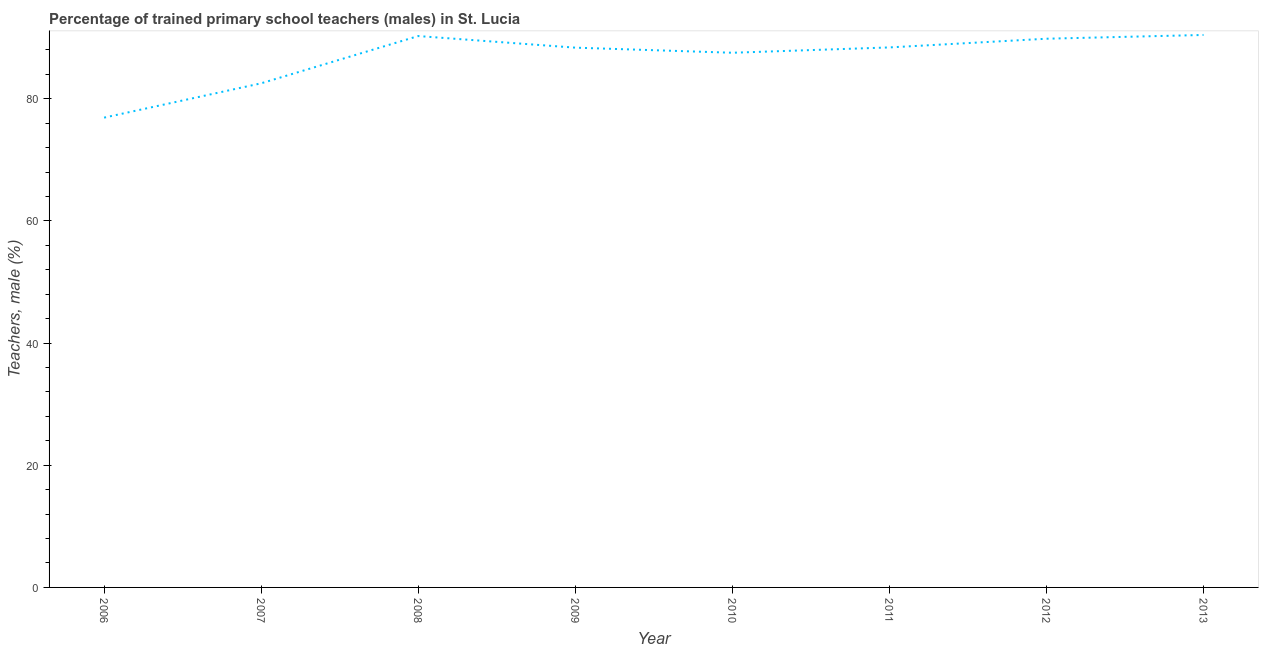What is the percentage of trained male teachers in 2012?
Your response must be concise. 89.82. Across all years, what is the maximum percentage of trained male teachers?
Keep it short and to the point. 90.44. Across all years, what is the minimum percentage of trained male teachers?
Provide a succinct answer. 76.91. In which year was the percentage of trained male teachers maximum?
Your answer should be very brief. 2013. In which year was the percentage of trained male teachers minimum?
Keep it short and to the point. 2006. What is the sum of the percentage of trained male teachers?
Provide a succinct answer. 694.25. What is the difference between the percentage of trained male teachers in 2008 and 2011?
Your answer should be very brief. 1.86. What is the average percentage of trained male teachers per year?
Ensure brevity in your answer.  86.78. What is the median percentage of trained male teachers?
Your response must be concise. 88.38. What is the ratio of the percentage of trained male teachers in 2010 to that in 2012?
Provide a succinct answer. 0.97. Is the percentage of trained male teachers in 2011 less than that in 2012?
Keep it short and to the point. Yes. What is the difference between the highest and the second highest percentage of trained male teachers?
Your answer should be very brief. 0.18. What is the difference between the highest and the lowest percentage of trained male teachers?
Your response must be concise. 13.53. In how many years, is the percentage of trained male teachers greater than the average percentage of trained male teachers taken over all years?
Your answer should be compact. 6. How many lines are there?
Provide a succinct answer. 1. How many years are there in the graph?
Your response must be concise. 8. What is the title of the graph?
Your answer should be very brief. Percentage of trained primary school teachers (males) in St. Lucia. What is the label or title of the X-axis?
Give a very brief answer. Year. What is the label or title of the Y-axis?
Make the answer very short. Teachers, male (%). What is the Teachers, male (%) of 2006?
Offer a terse response. 76.91. What is the Teachers, male (%) of 2007?
Give a very brief answer. 82.53. What is the Teachers, male (%) of 2008?
Provide a short and direct response. 90.26. What is the Teachers, male (%) of 2009?
Keep it short and to the point. 88.36. What is the Teachers, male (%) in 2010?
Provide a short and direct response. 87.53. What is the Teachers, male (%) of 2011?
Offer a very short reply. 88.4. What is the Teachers, male (%) of 2012?
Give a very brief answer. 89.82. What is the Teachers, male (%) in 2013?
Give a very brief answer. 90.44. What is the difference between the Teachers, male (%) in 2006 and 2007?
Provide a short and direct response. -5.62. What is the difference between the Teachers, male (%) in 2006 and 2008?
Provide a short and direct response. -13.36. What is the difference between the Teachers, male (%) in 2006 and 2009?
Your answer should be compact. -11.46. What is the difference between the Teachers, male (%) in 2006 and 2010?
Ensure brevity in your answer.  -10.62. What is the difference between the Teachers, male (%) in 2006 and 2011?
Keep it short and to the point. -11.49. What is the difference between the Teachers, male (%) in 2006 and 2012?
Offer a terse response. -12.92. What is the difference between the Teachers, male (%) in 2006 and 2013?
Your response must be concise. -13.53. What is the difference between the Teachers, male (%) in 2007 and 2008?
Ensure brevity in your answer.  -7.73. What is the difference between the Teachers, male (%) in 2007 and 2009?
Your answer should be very brief. -5.84. What is the difference between the Teachers, male (%) in 2007 and 2010?
Make the answer very short. -5. What is the difference between the Teachers, male (%) in 2007 and 2011?
Your answer should be very brief. -5.87. What is the difference between the Teachers, male (%) in 2007 and 2012?
Your answer should be compact. -7.3. What is the difference between the Teachers, male (%) in 2007 and 2013?
Your answer should be very brief. -7.91. What is the difference between the Teachers, male (%) in 2008 and 2009?
Your answer should be compact. 1.9. What is the difference between the Teachers, male (%) in 2008 and 2010?
Ensure brevity in your answer.  2.73. What is the difference between the Teachers, male (%) in 2008 and 2011?
Ensure brevity in your answer.  1.86. What is the difference between the Teachers, male (%) in 2008 and 2012?
Give a very brief answer. 0.44. What is the difference between the Teachers, male (%) in 2008 and 2013?
Make the answer very short. -0.18. What is the difference between the Teachers, male (%) in 2009 and 2010?
Your response must be concise. 0.83. What is the difference between the Teachers, male (%) in 2009 and 2011?
Keep it short and to the point. -0.04. What is the difference between the Teachers, male (%) in 2009 and 2012?
Provide a succinct answer. -1.46. What is the difference between the Teachers, male (%) in 2009 and 2013?
Give a very brief answer. -2.08. What is the difference between the Teachers, male (%) in 2010 and 2011?
Ensure brevity in your answer.  -0.87. What is the difference between the Teachers, male (%) in 2010 and 2012?
Your response must be concise. -2.3. What is the difference between the Teachers, male (%) in 2010 and 2013?
Offer a very short reply. -2.91. What is the difference between the Teachers, male (%) in 2011 and 2012?
Keep it short and to the point. -1.43. What is the difference between the Teachers, male (%) in 2011 and 2013?
Give a very brief answer. -2.04. What is the difference between the Teachers, male (%) in 2012 and 2013?
Ensure brevity in your answer.  -0.62. What is the ratio of the Teachers, male (%) in 2006 to that in 2007?
Your answer should be compact. 0.93. What is the ratio of the Teachers, male (%) in 2006 to that in 2008?
Provide a succinct answer. 0.85. What is the ratio of the Teachers, male (%) in 2006 to that in 2009?
Provide a succinct answer. 0.87. What is the ratio of the Teachers, male (%) in 2006 to that in 2010?
Your answer should be very brief. 0.88. What is the ratio of the Teachers, male (%) in 2006 to that in 2011?
Your answer should be very brief. 0.87. What is the ratio of the Teachers, male (%) in 2006 to that in 2012?
Your answer should be very brief. 0.86. What is the ratio of the Teachers, male (%) in 2006 to that in 2013?
Provide a succinct answer. 0.85. What is the ratio of the Teachers, male (%) in 2007 to that in 2008?
Provide a succinct answer. 0.91. What is the ratio of the Teachers, male (%) in 2007 to that in 2009?
Ensure brevity in your answer.  0.93. What is the ratio of the Teachers, male (%) in 2007 to that in 2010?
Provide a short and direct response. 0.94. What is the ratio of the Teachers, male (%) in 2007 to that in 2011?
Give a very brief answer. 0.93. What is the ratio of the Teachers, male (%) in 2007 to that in 2012?
Offer a very short reply. 0.92. What is the ratio of the Teachers, male (%) in 2007 to that in 2013?
Provide a short and direct response. 0.91. What is the ratio of the Teachers, male (%) in 2008 to that in 2010?
Make the answer very short. 1.03. What is the ratio of the Teachers, male (%) in 2008 to that in 2011?
Offer a terse response. 1.02. What is the ratio of the Teachers, male (%) in 2008 to that in 2012?
Give a very brief answer. 1. What is the ratio of the Teachers, male (%) in 2009 to that in 2010?
Provide a short and direct response. 1.01. What is the ratio of the Teachers, male (%) in 2009 to that in 2012?
Make the answer very short. 0.98. What is the ratio of the Teachers, male (%) in 2010 to that in 2011?
Ensure brevity in your answer.  0.99. What is the ratio of the Teachers, male (%) in 2010 to that in 2012?
Ensure brevity in your answer.  0.97. What is the ratio of the Teachers, male (%) in 2011 to that in 2013?
Provide a short and direct response. 0.98. 